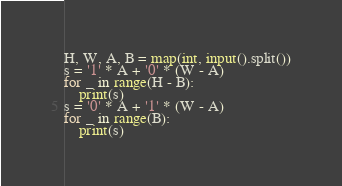<code> <loc_0><loc_0><loc_500><loc_500><_Python_>H, W, A, B = map(int, input().split())
s = '1' * A + '0' * (W - A)
for _ in range(H - B):
    print(s)
s = '0' * A + '1' * (W - A)
for _ in range(B):
    print(s)</code> 